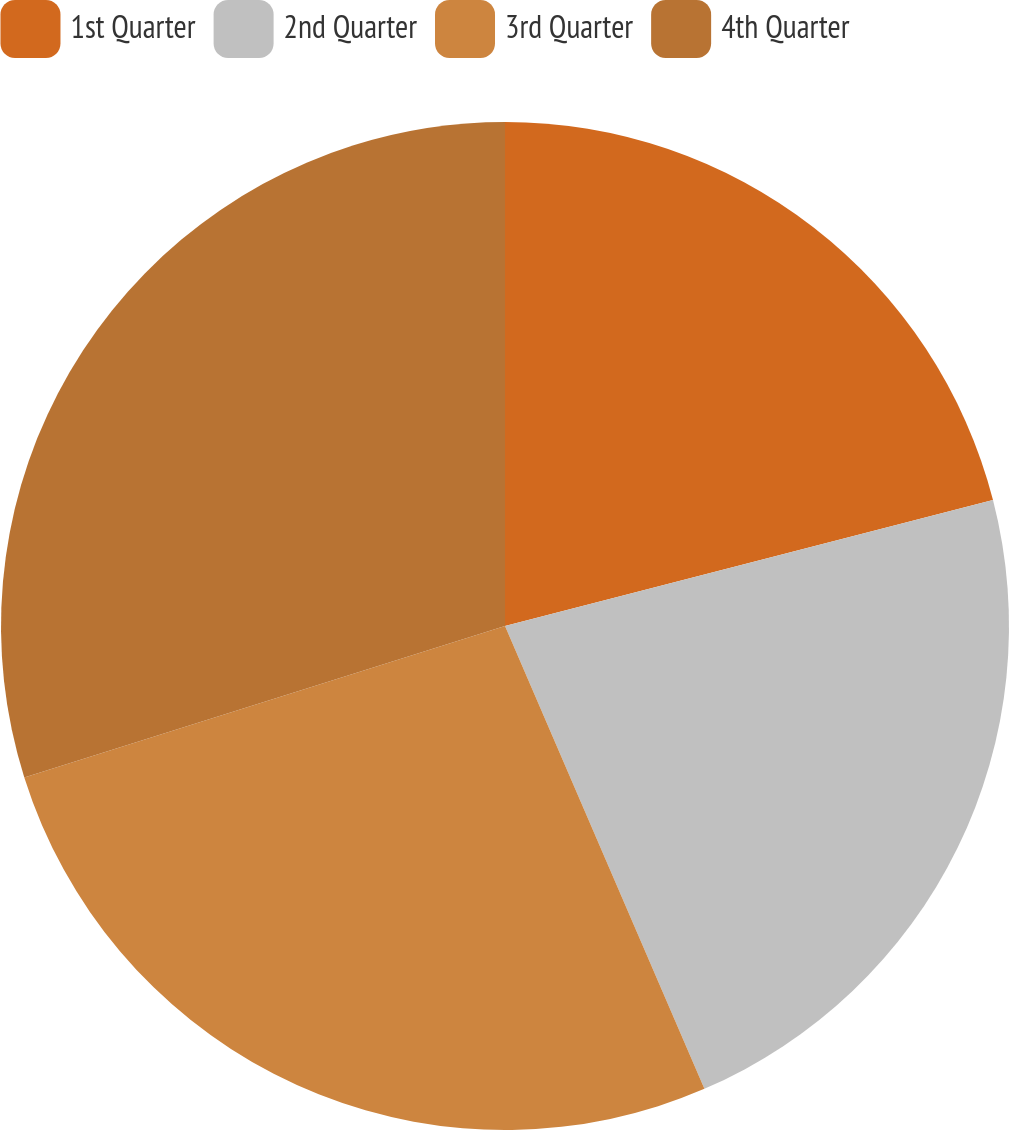Convert chart. <chart><loc_0><loc_0><loc_500><loc_500><pie_chart><fcel>1st Quarter<fcel>2nd Quarter<fcel>3rd Quarter<fcel>4th Quarter<nl><fcel>20.98%<fcel>22.55%<fcel>26.62%<fcel>29.86%<nl></chart> 